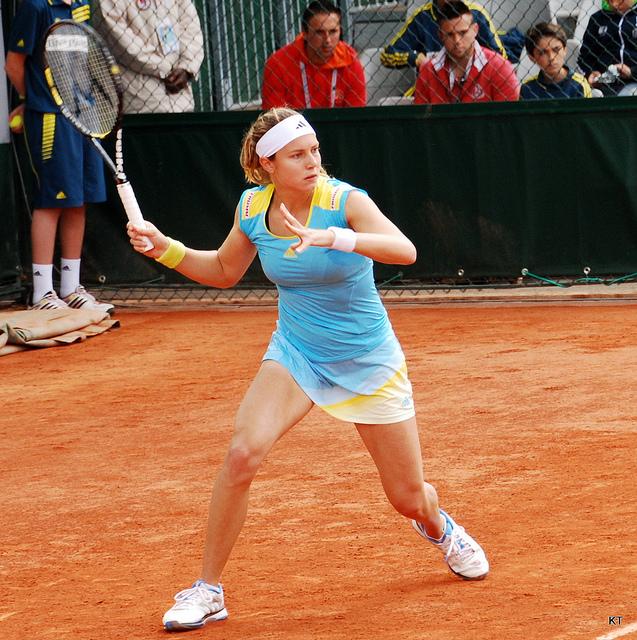Who is watching?
Keep it brief. People. What is the main color of the woman's outfit?
Answer briefly. Blue. Is the lady about to hit the ball?
Keep it brief. Yes. What are the colors of her tennis racket?
Keep it brief. Black, yellow, and white. What hand is she holding the racket with?
Quick response, please. Right. Are the women playing a single or doubles match?
Give a very brief answer. Single. 